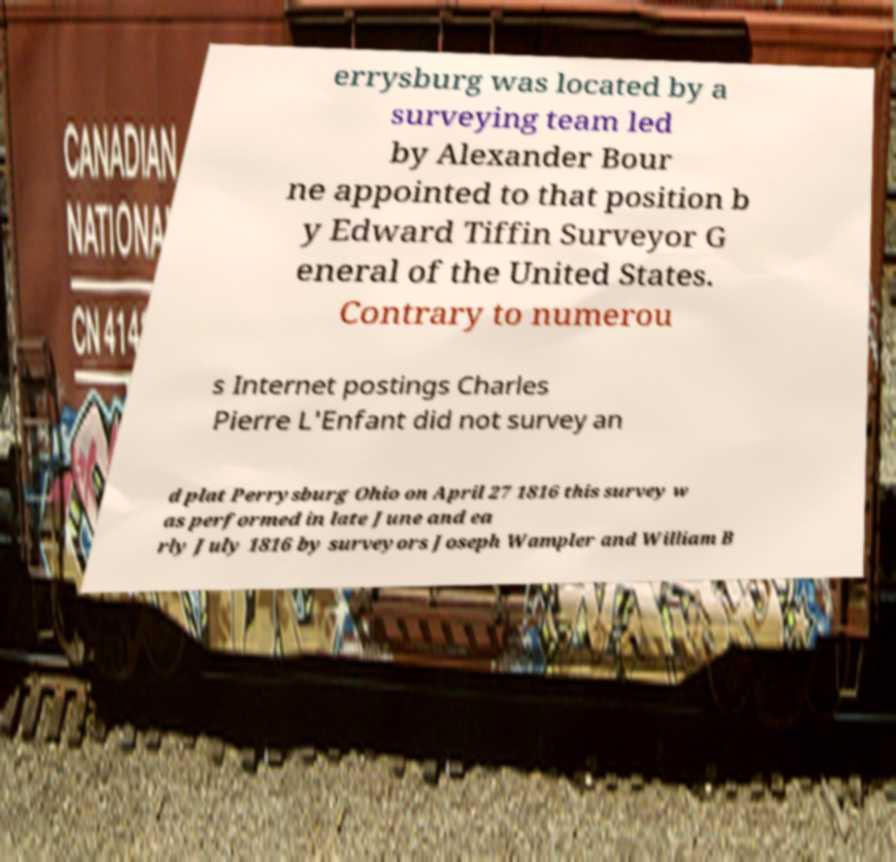Could you assist in decoding the text presented in this image and type it out clearly? errysburg was located by a surveying team led by Alexander Bour ne appointed to that position b y Edward Tiffin Surveyor G eneral of the United States. Contrary to numerou s Internet postings Charles Pierre L'Enfant did not survey an d plat Perrysburg Ohio on April 27 1816 this survey w as performed in late June and ea rly July 1816 by surveyors Joseph Wampler and William B 